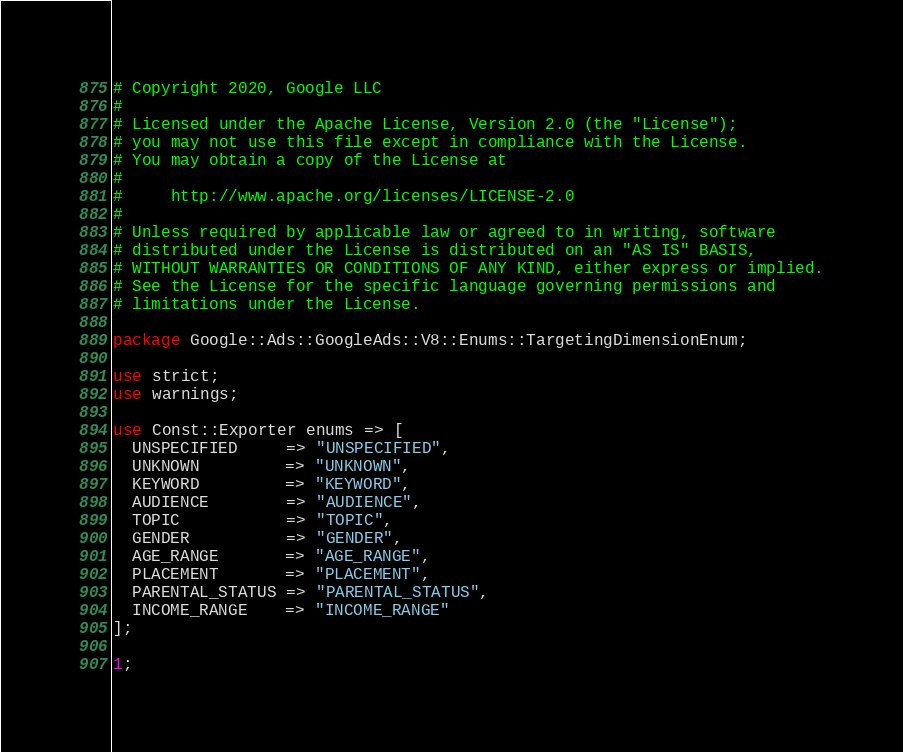Convert code to text. <code><loc_0><loc_0><loc_500><loc_500><_Perl_># Copyright 2020, Google LLC
#
# Licensed under the Apache License, Version 2.0 (the "License");
# you may not use this file except in compliance with the License.
# You may obtain a copy of the License at
#
#     http://www.apache.org/licenses/LICENSE-2.0
#
# Unless required by applicable law or agreed to in writing, software
# distributed under the License is distributed on an "AS IS" BASIS,
# WITHOUT WARRANTIES OR CONDITIONS OF ANY KIND, either express or implied.
# See the License for the specific language governing permissions and
# limitations under the License.

package Google::Ads::GoogleAds::V8::Enums::TargetingDimensionEnum;

use strict;
use warnings;

use Const::Exporter enums => [
  UNSPECIFIED     => "UNSPECIFIED",
  UNKNOWN         => "UNKNOWN",
  KEYWORD         => "KEYWORD",
  AUDIENCE        => "AUDIENCE",
  TOPIC           => "TOPIC",
  GENDER          => "GENDER",
  AGE_RANGE       => "AGE_RANGE",
  PLACEMENT       => "PLACEMENT",
  PARENTAL_STATUS => "PARENTAL_STATUS",
  INCOME_RANGE    => "INCOME_RANGE"
];

1;
</code> 